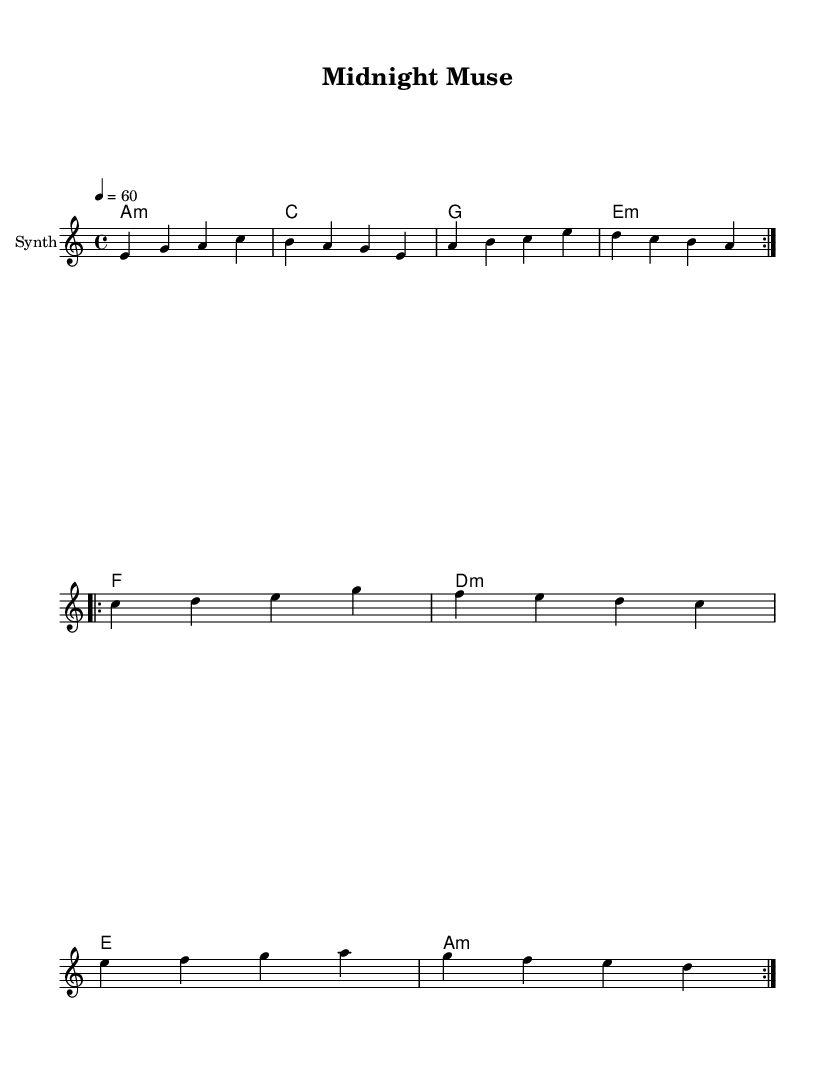What is the key signature of this music? The music is in A minor, which is indicated by the 'a' on the key signature line and has no sharps or flats.
Answer: A minor What is the time signature of this music? The time signature appears as '4/4' in the beginning, denoting four beats per measure and a quarter note gets one beat.
Answer: 4/4 What is the tempo marking of the piece? The tempo marking shows '4 = 60', which means there are sixty beats per minute.
Answer: 60 How many measures are in the main theme A? The main theme A contains 4 measures, consisting of distinct musical phrases outlined in the notation.
Answer: 4 What chord is played for the first measure? The first measure shows 'a1:m', indicating the A minor chord is played.
Answer: A minor How many times is main theme A repeated? The score indicates that main theme A is repeated 2 times, as denoted by 'repeat volta 2'.
Answer: 2 What is the primary instrument indicated in the score? The score specifies the instrument name as "Synth", indicating that this is a synthesized electronic piece.
Answer: Synth 